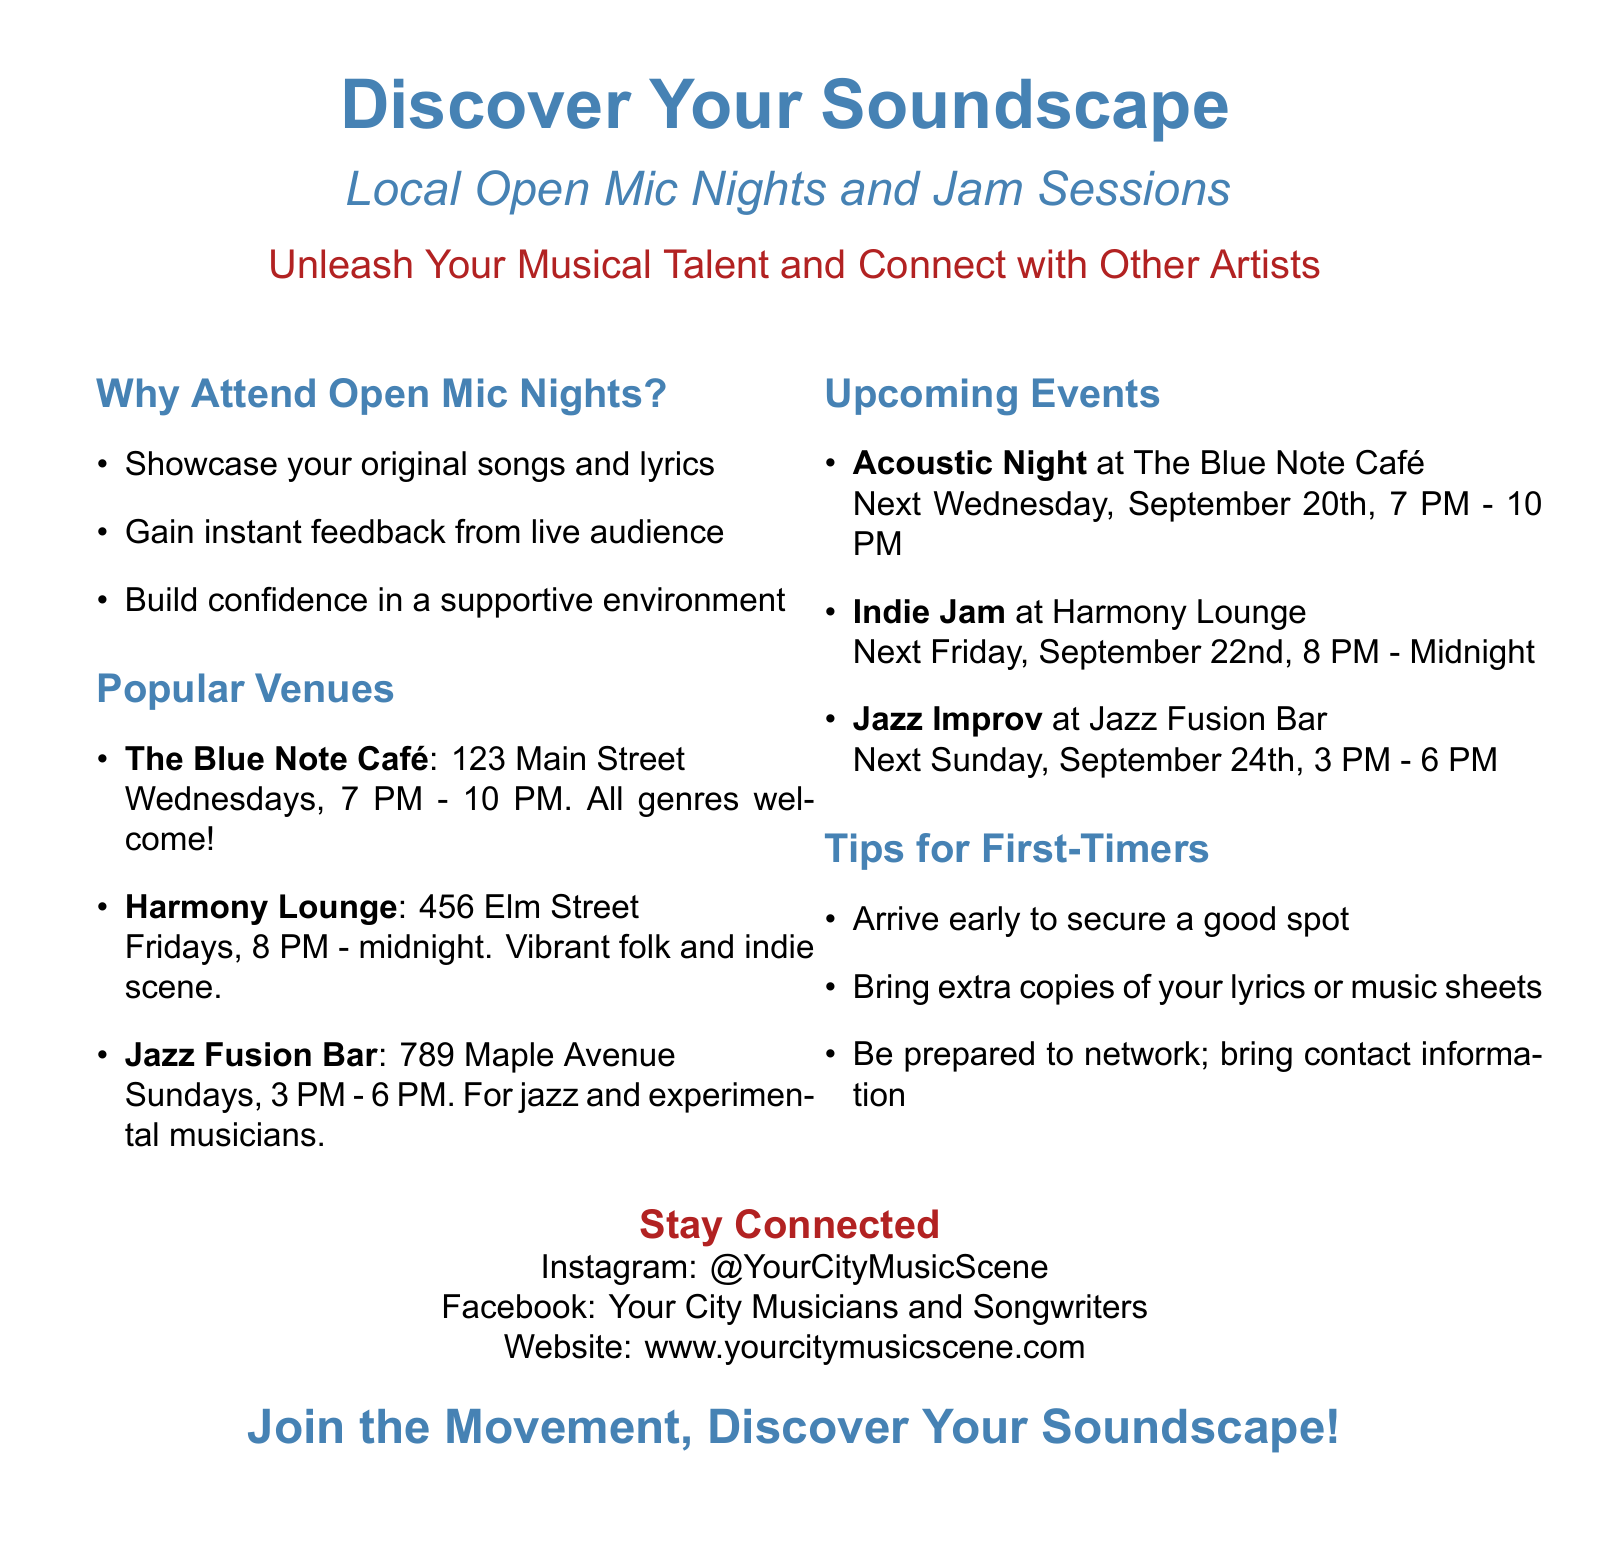What is the title of the event? The title of the event is highlighted at the top of the document, prominently stating "Discover Your Soundscape."
Answer: Discover Your Soundscape When does the Acoustic Night take place? The date and time for the Acoustic Night are listed under Upcoming Events, specifically mentioning September 20th from 7 PM to 10 PM.
Answer: September 20th, 7 PM - 10 PM What genre is featured at the Jazz Fusion Bar? The document specifies that the Jazz Fusion Bar is for jazz and experimental musicians.
Answer: Jazz and experimental How many venues are listed in the Popular Venues section? The Popular Venues section includes three distinct venues mentioned.
Answer: Three What is one tip for first-timers attending these events? The Tips for First-Timers section advises arriving early to secure a good spot.
Answer: Arrive early What is the Instagram handle provided for staying connected? The document provides the Instagram handle as @YourCityMusicScene.
Answer: @YourCityMusicScene What time do the events at Harmony Lounge start on Fridays? The document states that events at Harmony Lounge begin at 8 PM on Fridays.
Answer: 8 PM What type of music scene can participants expect at Harmony Lounge? The text describes the Harmony Lounge as having a vibrant folk and indie scene.
Answer: Folk and indie scene 